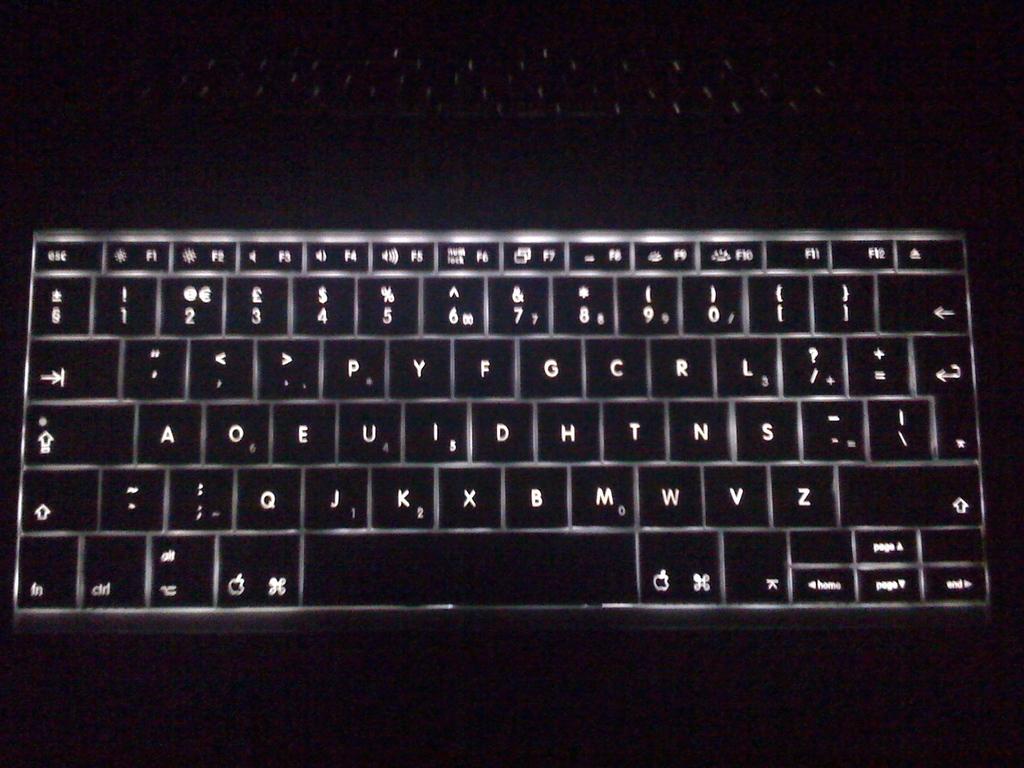What number is written on the "j" key?
Provide a short and direct response. 1. 